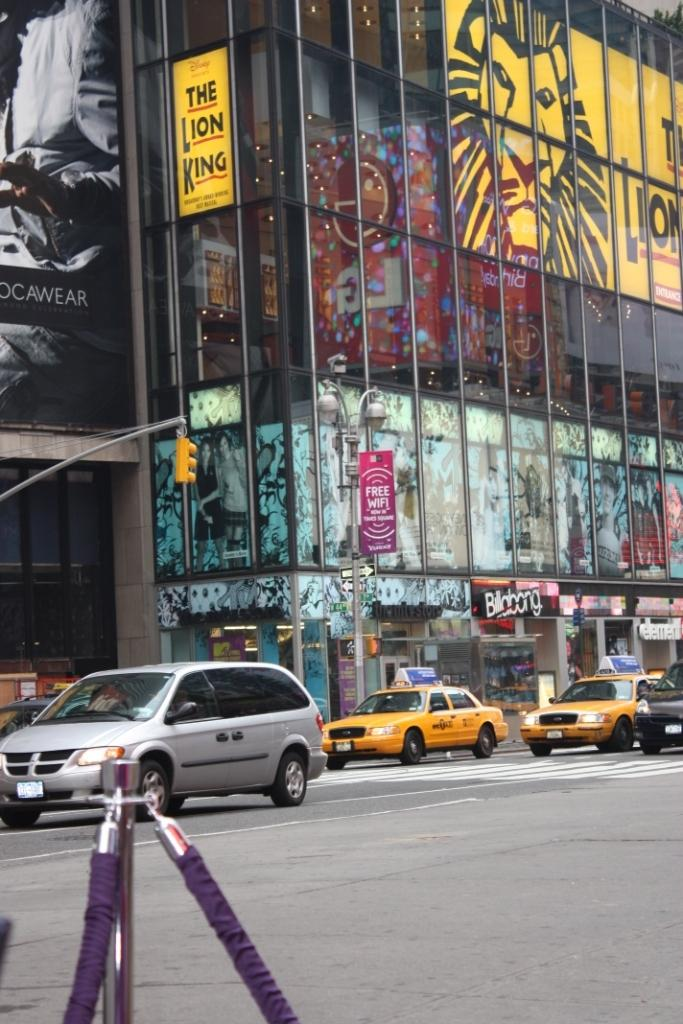<image>
Present a compact description of the photo's key features. A number of cars drive down the street under a Lion King ad. 